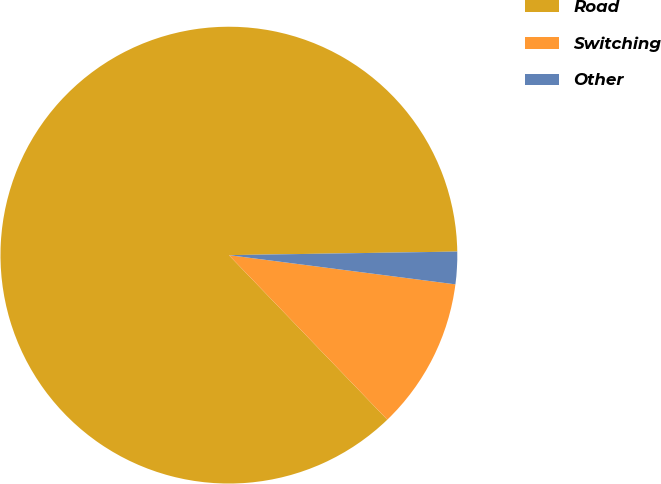Convert chart. <chart><loc_0><loc_0><loc_500><loc_500><pie_chart><fcel>Road<fcel>Switching<fcel>Other<nl><fcel>86.95%<fcel>10.76%<fcel>2.29%<nl></chart> 